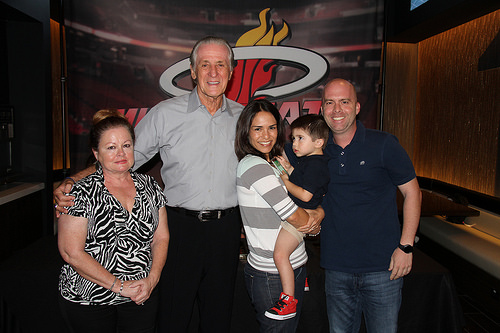<image>
Can you confirm if the flame is on the wall? Yes. Looking at the image, I can see the flame is positioned on top of the wall, with the wall providing support. 